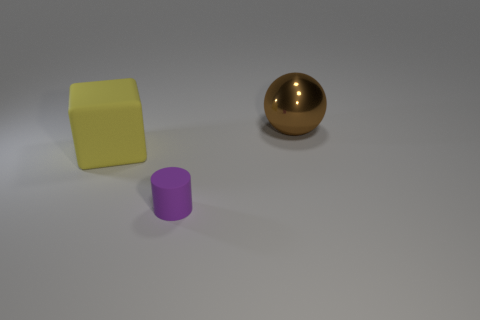Add 3 large things. How many objects exist? 6 Subtract all cylinders. How many objects are left? 2 Add 2 purple cylinders. How many purple cylinders are left? 3 Add 3 tiny blue cylinders. How many tiny blue cylinders exist? 3 Subtract 0 cyan balls. How many objects are left? 3 Subtract all tiny rubber balls. Subtract all brown metal balls. How many objects are left? 2 